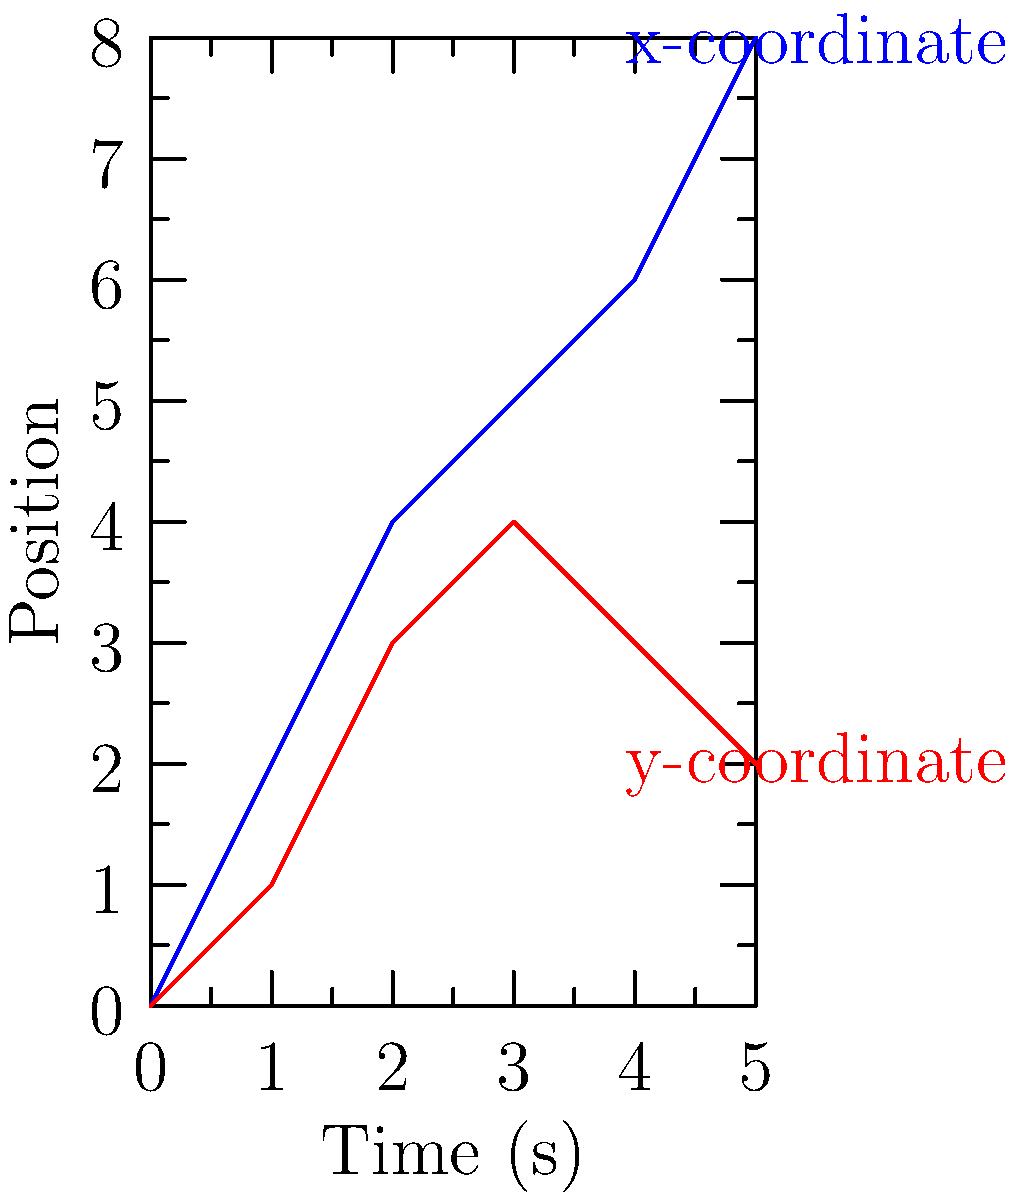The graph shows the x and y coordinates of a Mario Kart character's trajectory over time during a race. Based on the graph, at what time does the character reach their maximum y-coordinate, and what is the corresponding x-coordinate at that moment? To solve this problem, we need to follow these steps:

1. Identify the maximum y-coordinate:
   Looking at the red line (y-coordinate), we can see that it reaches its peak at y = 4.

2. Determine the time at which this maximum occurs:
   The y-coordinate reaches 4 at t = 3 seconds.

3. Find the corresponding x-coordinate:
   At t = 3 seconds, the blue line (x-coordinate) shows a value of 5.

Therefore, the character reaches their maximum y-coordinate at t = 3 seconds, and at that moment, their x-coordinate is 5.

This analysis demonstrates how we can use coordinate systems to track the movement of objects in both space and time, which is relevant to both environmental science (e.g., tracking animal movements) and video game mechanics.
Answer: Time: 3 seconds; x-coordinate: 5 